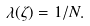Convert formula to latex. <formula><loc_0><loc_0><loc_500><loc_500>\lambda ( \zeta ) = 1 / N .</formula> 